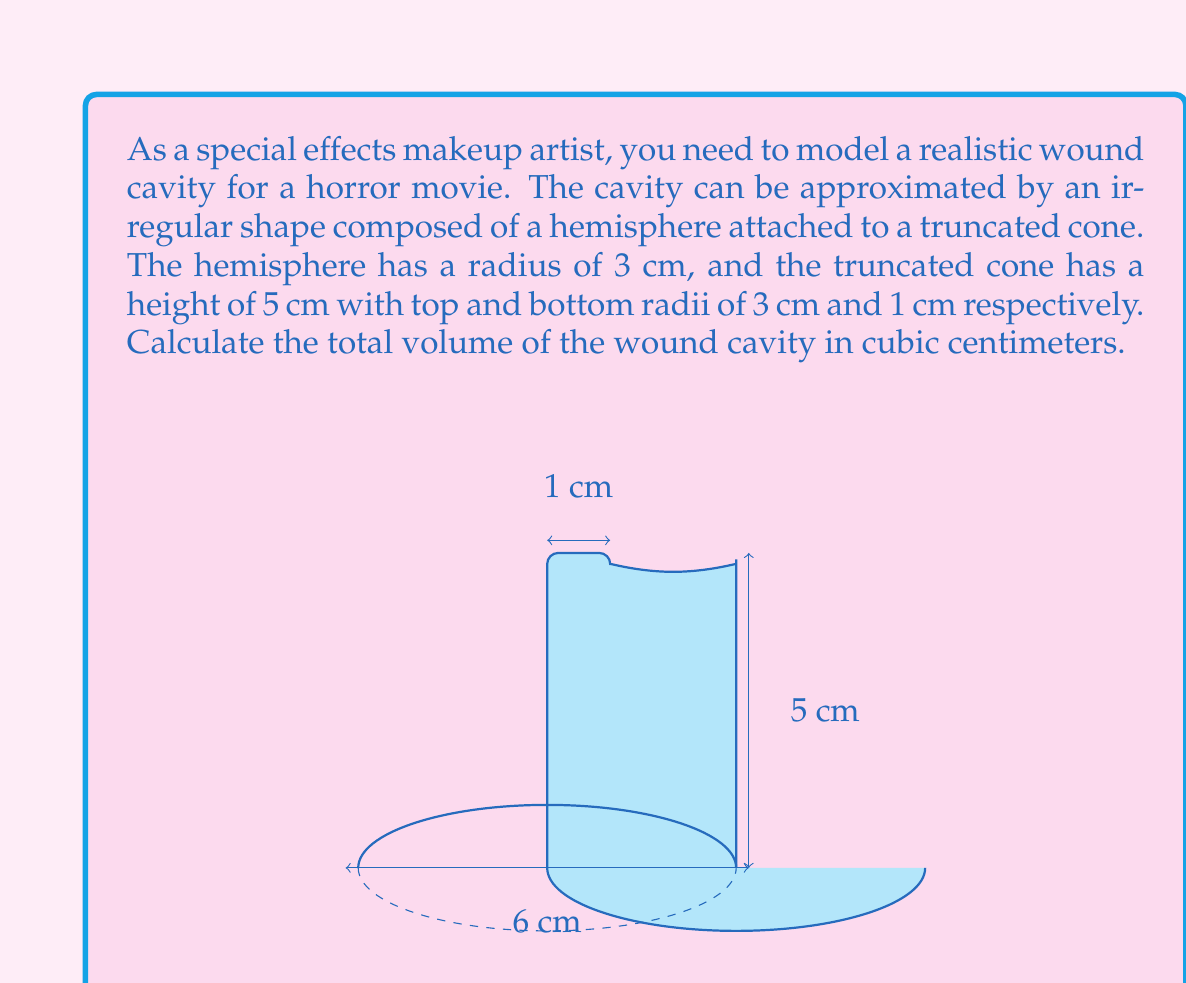Provide a solution to this math problem. To calculate the total volume of the wound cavity, we need to sum the volumes of the hemisphere and the truncated cone.

1. Volume of the hemisphere:
   The formula for the volume of a hemisphere is:
   $$V_h = \frac{2}{3}\pi r^3$$
   Where $r$ is the radius of the hemisphere.
   $$V_h = \frac{2}{3}\pi (3\text{ cm})^3 = 18\pi \text{ cm}^3$$

2. Volume of the truncated cone:
   The formula for the volume of a truncated cone is:
   $$V_c = \frac{1}{3}\pi h(R^2 + r^2 + Rr)$$
   Where $h$ is the height, $R$ is the radius of the base, and $r$ is the radius of the top.
   $$V_c = \frac{1}{3}\pi (5\text{ cm})((3\text{ cm})^2 + (1\text{ cm})^2 + 3\text{ cm} \cdot 1\text{ cm})$$
   $$V_c = \frac{1}{3}\pi (5)(9 + 1 + 3) = \frac{65\pi}{3} \text{ cm}^3$$

3. Total volume:
   $$V_{\text{total}} = V_h + V_c = 18\pi \text{ cm}^3 + \frac{65\pi}{3} \text{ cm}^3 = \frac{119\pi}{3} \text{ cm}^3$$

4. Simplifying the result:
   $$V_{\text{total}} = \frac{119\pi}{3} \approx 124.35 \text{ cm}^3$$
Answer: $124.35 \text{ cm}^3$ 